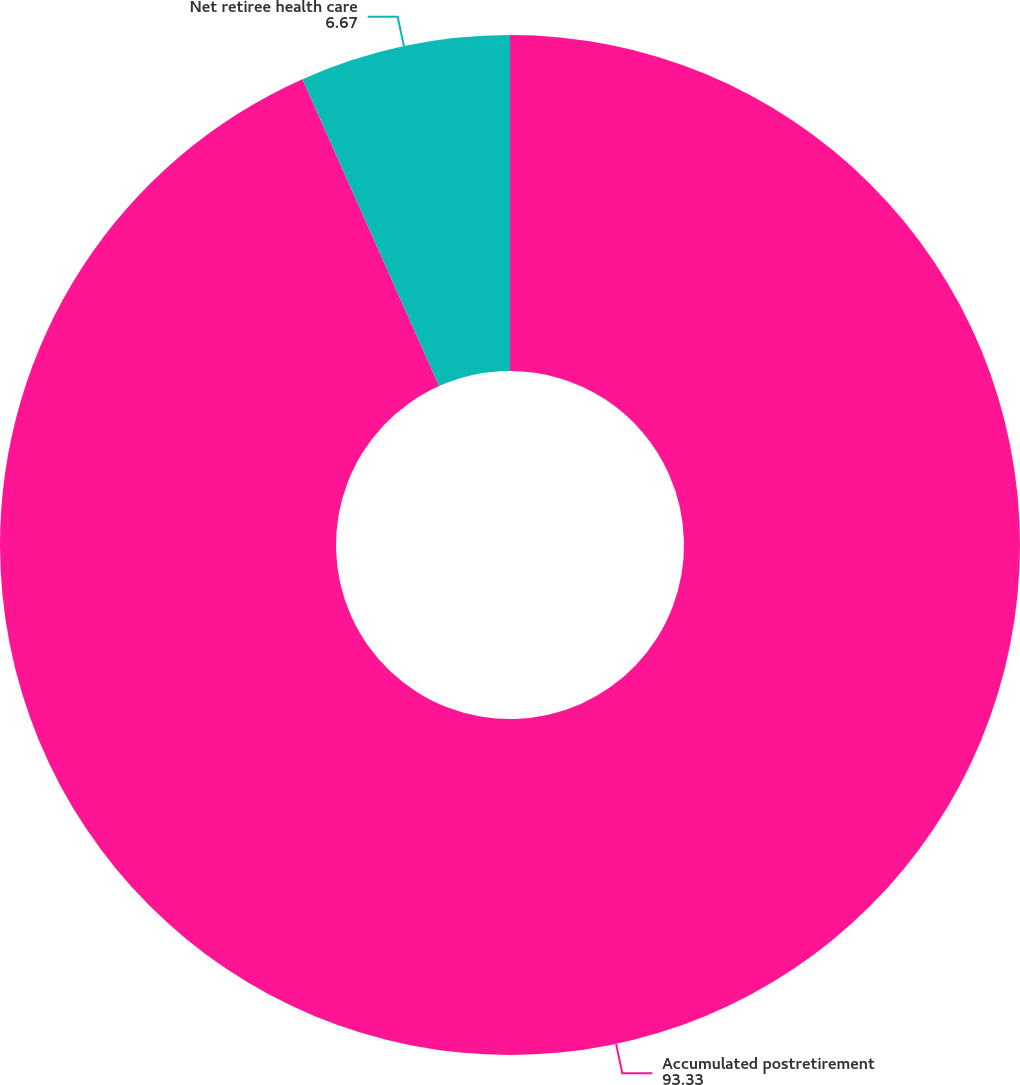<chart> <loc_0><loc_0><loc_500><loc_500><pie_chart><fcel>Accumulated postretirement<fcel>Net retiree health care<nl><fcel>93.33%<fcel>6.67%<nl></chart> 